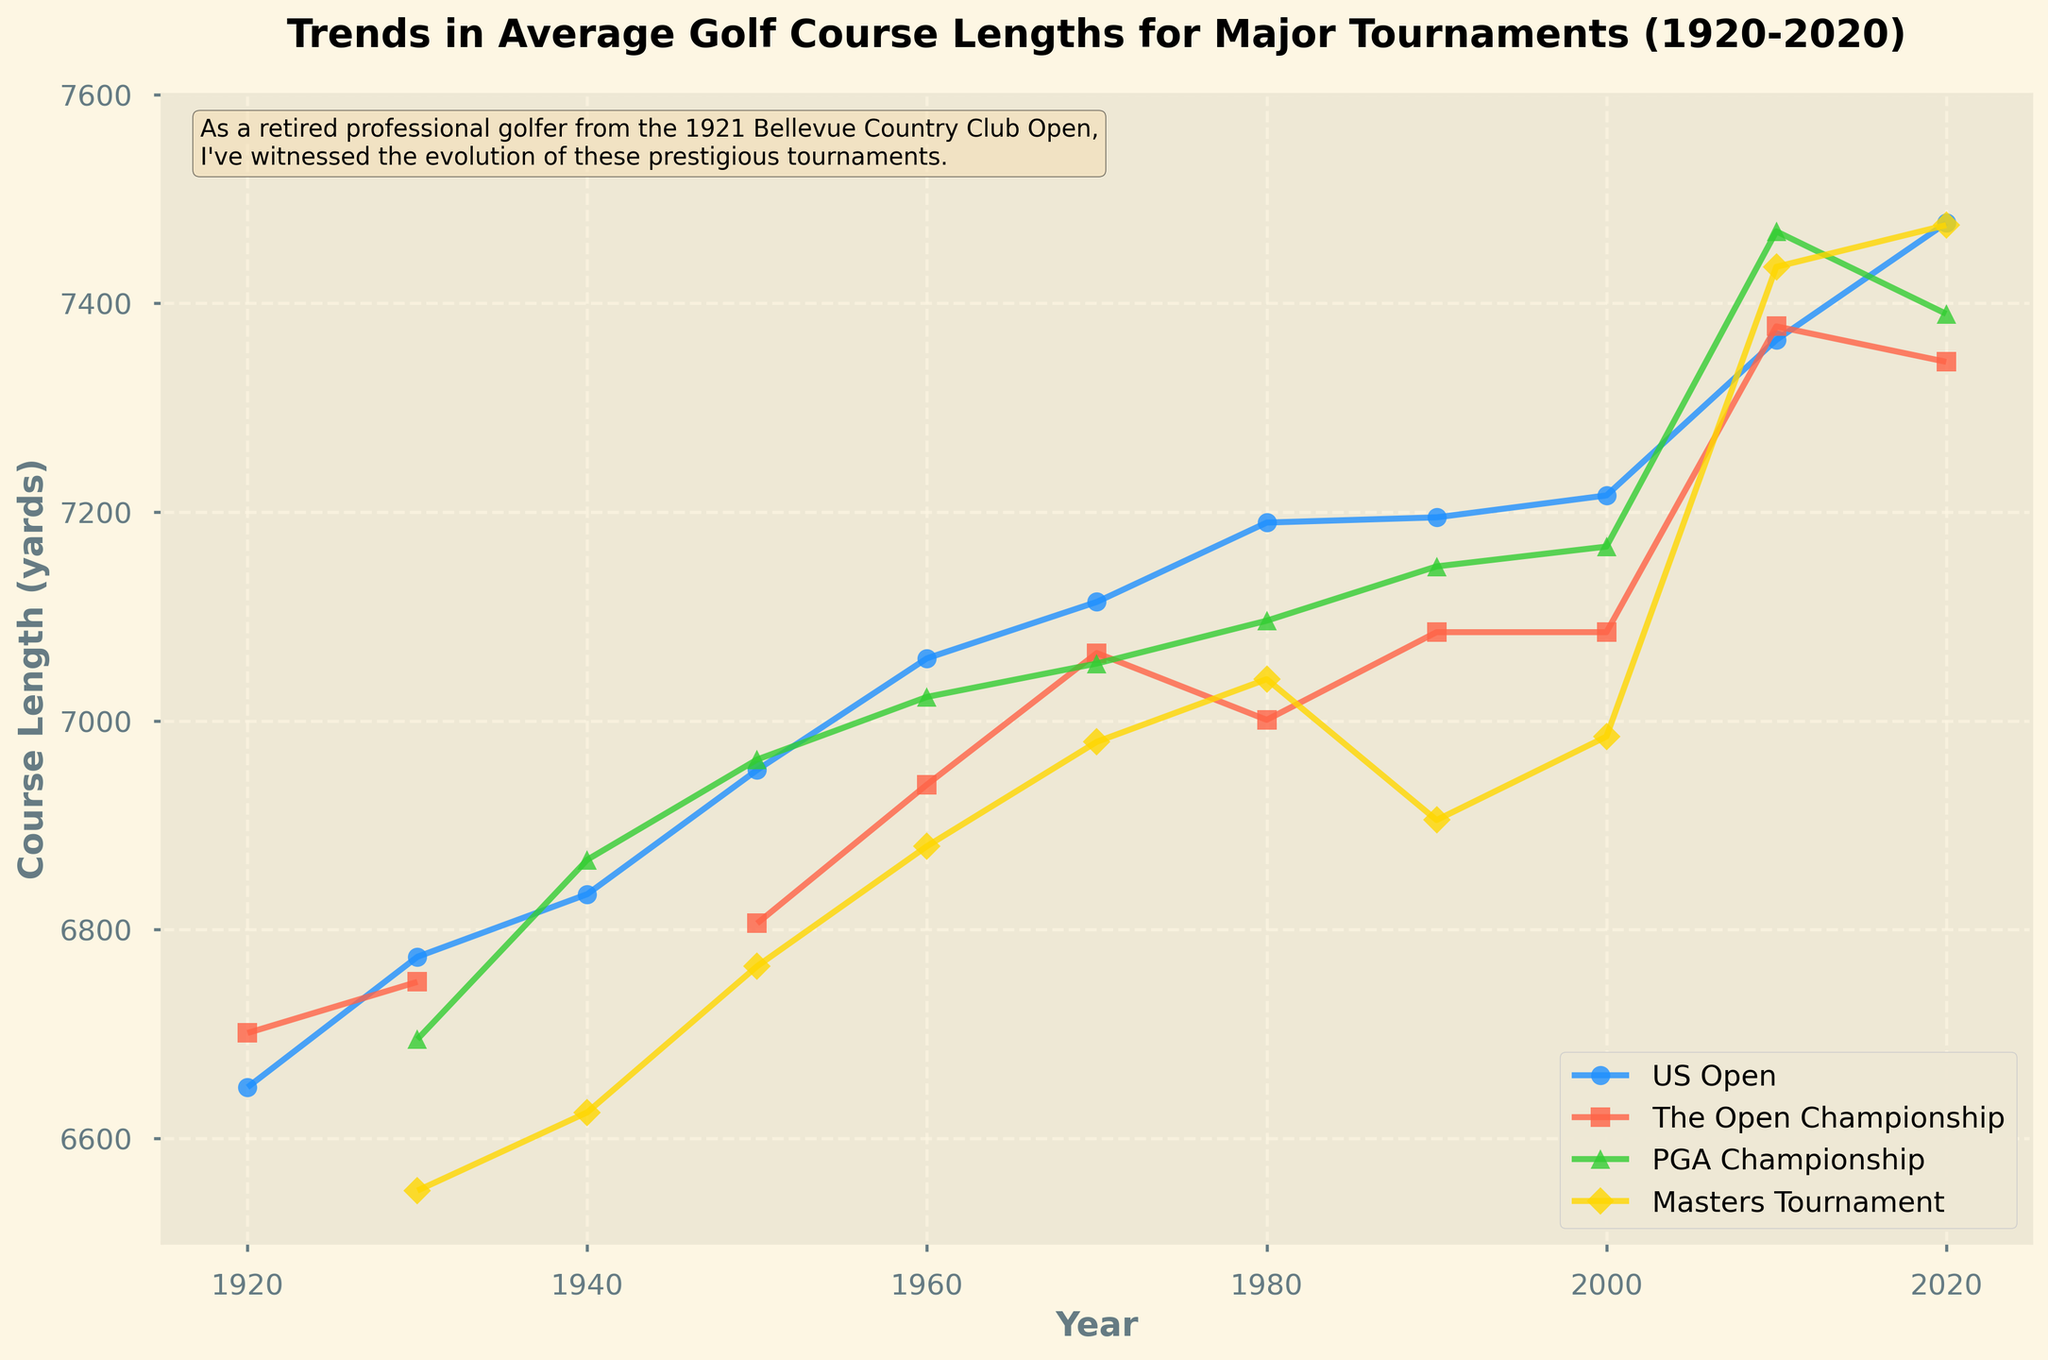Which tournament experienced the greatest increase in course length from 1920 to 2020? Compare the course length in 1920 and 2020 for each tournament. The US Open’s length increased from 6649 yards in 1920 to 7477 yards in 2020, a change of 828 yards. For The Open Championship, the increase was from 6701 to 7344 (643 yards). Note that PGA and Masters length data from 1920 isn’t available; hence they cannot be compared directly for the entire range.
Answer: US Open What is the overall trend in the length of golf courses for major tournaments from 1920 to 2020? Observing the line chart, each line representing a major tournament shows an upward trend from 1920 to 2020.
Answer: Increasing In what year did the Masters Tournament first appear on the chart, and what was its course length? Spot the first year where the Masters Tournament line appears on the chart, which is 1930, with a course length of 6550 yards.
Answer: 1930, 6550 yards How does the average course length of the US Open compare to The Open Championship in 2020? Look at the course lengths in 2020 for the US Open (7477 yards) and The Open Championship (7344 yards). Subtract to find the difference: 7477 - 7344 = 133 yards.
Answer: US Open is 133 yards longer What visual attributes differentiate the line representing the US Open from others? Observe the color and marker shape. The US Open line is blue with circle markers.
Answer: Blue, circles During which decade did the PGA Championship see the smallest change in course length? Examine the PGA Championship line to find minimal changes. From 2000 (7167 yards) to 2010 (7469 yards), it increased by 302 yards, while from 1990 (7148 yards) to 2000 (7167 yards), it increased only by 19 yards, indicating the smallest change.
Answer: 1990s What can be inferred about the course lengths between 1960 and 1970 for all tournaments? The chart shows all lines increasing in height between 1960 and 1970. This indicates all tournament courses lengthened during that period.
Answer: All courses got longer Is there any year where two or more tournaments had nearly the same course length? If so, which tournaments and what were the lengths? Look closely at years where lines converge. In 1930, the US Open (6774 yards) and The Open Championship (6750 yards) had lengths differing by only 24 yards.
Answer: US Open and The Open Championship in 1930, nearly equal lengths By how many yards did the Masters Tournament course increase from 1930 to 2020? Identify the course lengths for the Masters in 1930 (6550 yards) and 2020 (7475 yards). Their difference is 7475 - 6550 = 925 yards.
Answer: 925 yards Which tournament had the least overall increase in course length from its earliest data point to 2020? Examine individual starting and ending points. The Open Championship increased from 6701 yards in 1920 to 7344 yards in 2020, an increase of 643 yards, the least among those tracked from 1920 or earliest data points available.
Answer: The Open Championship 